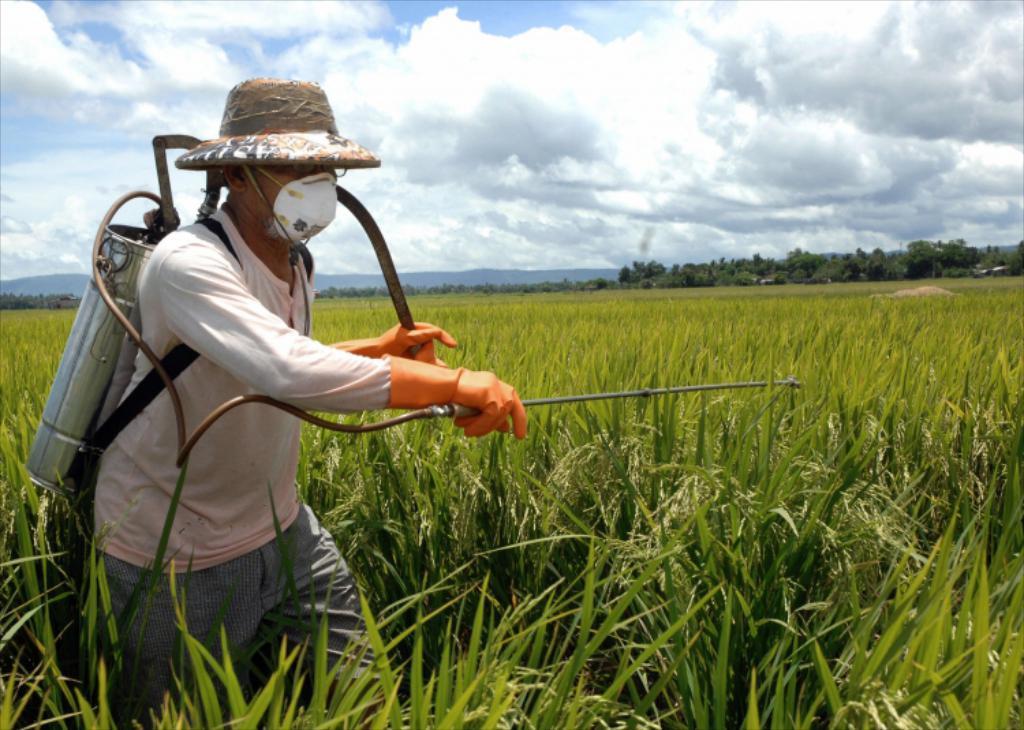Can you describe this image briefly? In this picture I can see a person with an agriculture spray machine, there is grass, plants, trees, and in the background there is sky. 